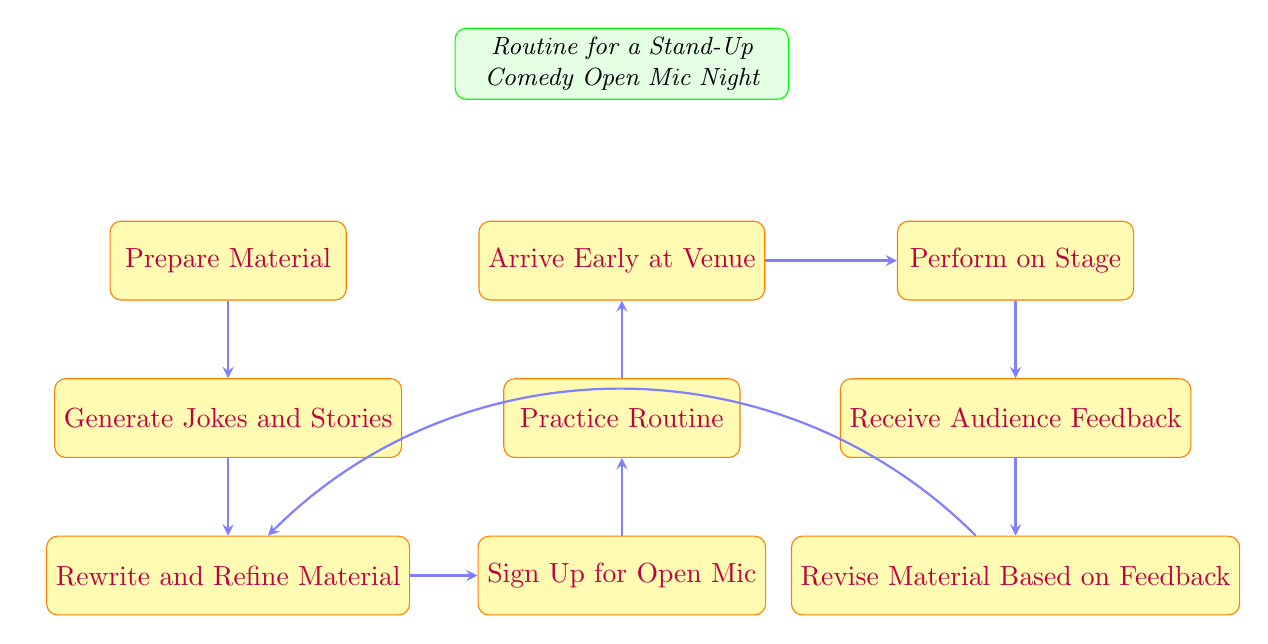What is the starting point of the routine? The diagram indicates that the starting point of the routine is "Prepare Material." This is the first node listed in the diagram.
Answer: Prepare Material How many nodes are in the flow chart? The flow chart contains a total of 9 nodes, which include each step of the comedy routine. These are distinct stages from start to feedback.
Answer: 9 What comes after "Sign Up for Open Mic"? The flow chart shows that "Practice Routine" is the next step that follows "Sign Up for Open Mic." This indicates that after signing up, practicing is essential.
Answer: Practice Routine What is the last step of the routine? According to the flow chart, the last step is "Revise Material Based on Feedback," which is the final node that follows receiving audience feedback.
Answer: Revise Material Based on Feedback How does one reach "Perform on Stage"? To reach "Perform on Stage," one must progress through several steps: starting with "Prepare Material," then "Generate Jokes and Stories," "Rewrite and Refine Material," "Sign Up for Open Mic," "Practice Routine," and "Arrive Early at Venue." This sequence shows the flow towards performing.
Answer: Through 6 steps What happens after receiving audience feedback? After receiving feedback from the audience, the next action is to "Revise Material Based on Feedback," suggesting that feedback directly influences content improvement.
Answer: Revise Material Based on Feedback Which node is connected to "Revise" and "Rewrite"? The node "Revise" is connected to "Feedback" and has a backward connection to "Rewrite." This depicts a loop where feedback leads to revising, which can cycle back to rewriting material.
Answer: Feedback and Rewrite What is the primary flow direction of the diagram? The primary flow direction moves from top to bottom and then from left to right at specific sections, indicating the sequential process of preparing for a stand-up performance in an ordered manner.
Answer: Top to bottom, left to right What is the relationship between "Practice Routine" and "Arrive Early at Venue"? The diagram shows a direct sequence where "Practice Routine" leads to "Arrive Early at Venue," indicating that practicing must be accomplished before arriving at the venue.
Answer: Sequential relationship 